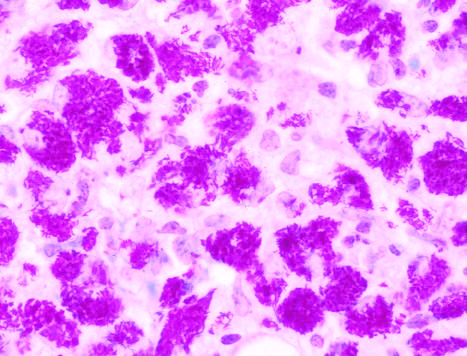re the media of the artery seen in this specimen from an immunosuppressed patient?
Answer the question using a single word or phrase. No 